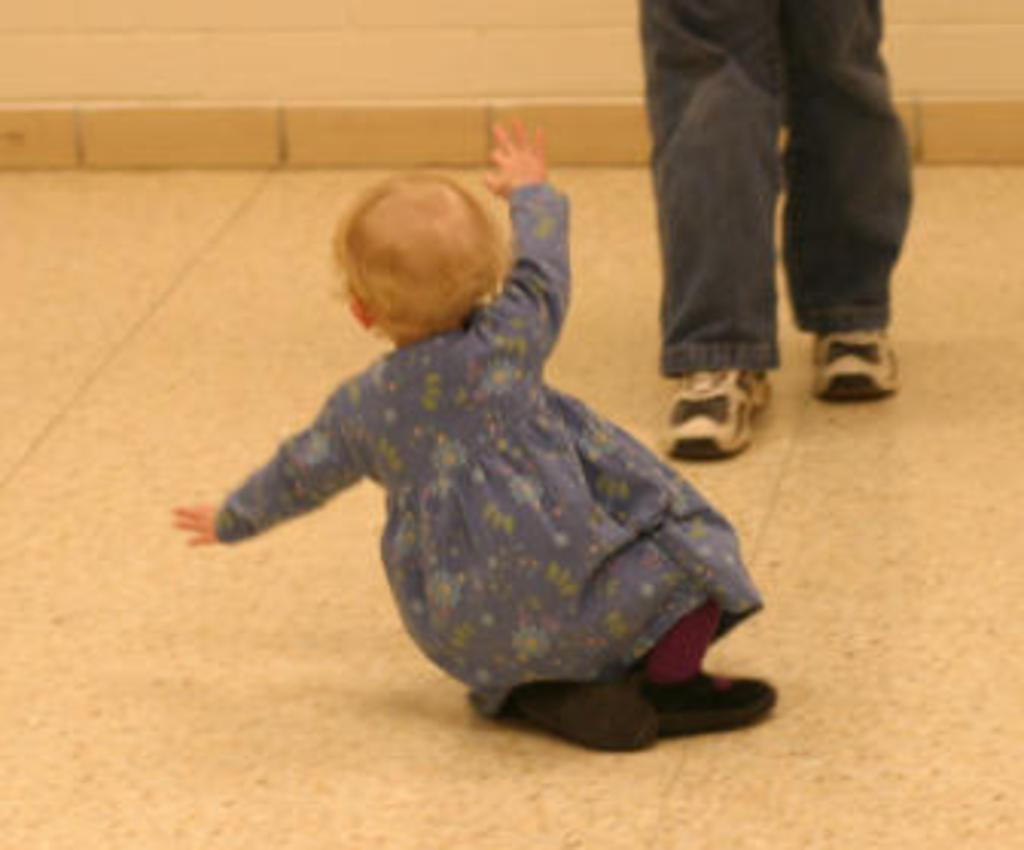What is the main subject of the image? There is a baby in the image. What can be seen beneath the baby? The floor is visible in the image. Whose legs are present in the image? The legs of a person are present in the image. What type of chain is being used to hold the baby in the image? There is no chain present in the image; the baby is not being held by any restraints. 